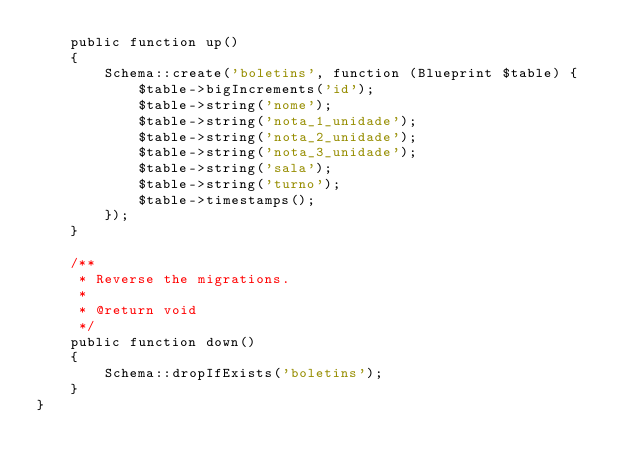<code> <loc_0><loc_0><loc_500><loc_500><_PHP_>    public function up()
    {
        Schema::create('boletins', function (Blueprint $table) {
            $table->bigIncrements('id');
            $table->string('nome');
            $table->string('nota_1_unidade');
            $table->string('nota_2_unidade');
            $table->string('nota_3_unidade');
            $table->string('sala');
            $table->string('turno');
            $table->timestamps();
        });
    }

    /**
     * Reverse the migrations.
     *
     * @return void
     */
    public function down()
    {
        Schema::dropIfExists('boletins');
    }
}
</code> 